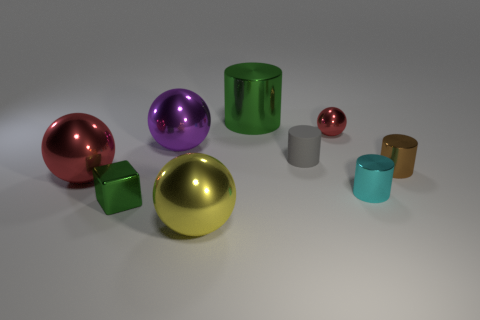Subtract all gray rubber cylinders. How many cylinders are left? 3 Subtract all red spheres. How many spheres are left? 2 Subtract all cylinders. How many objects are left? 5 Subtract 3 cylinders. How many cylinders are left? 1 Subtract all yellow blocks. Subtract all cyan cylinders. How many blocks are left? 1 Subtract all purple cylinders. How many yellow spheres are left? 1 Subtract all large purple metal things. Subtract all large shiny things. How many objects are left? 4 Add 7 tiny metallic blocks. How many tiny metallic blocks are left? 8 Add 2 big blue metallic objects. How many big blue metallic objects exist? 2 Subtract 1 brown cylinders. How many objects are left? 8 